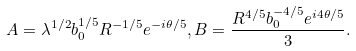Convert formula to latex. <formula><loc_0><loc_0><loc_500><loc_500>A = \lambda ^ { 1 / 2 } b _ { 0 } ^ { 1 / 5 } R ^ { - 1 / 5 } e ^ { - i \theta / 5 } , B = \frac { R ^ { 4 / 5 } b _ { 0 } ^ { - 4 / 5 } e ^ { i 4 \theta / 5 } } { 3 } .</formula> 